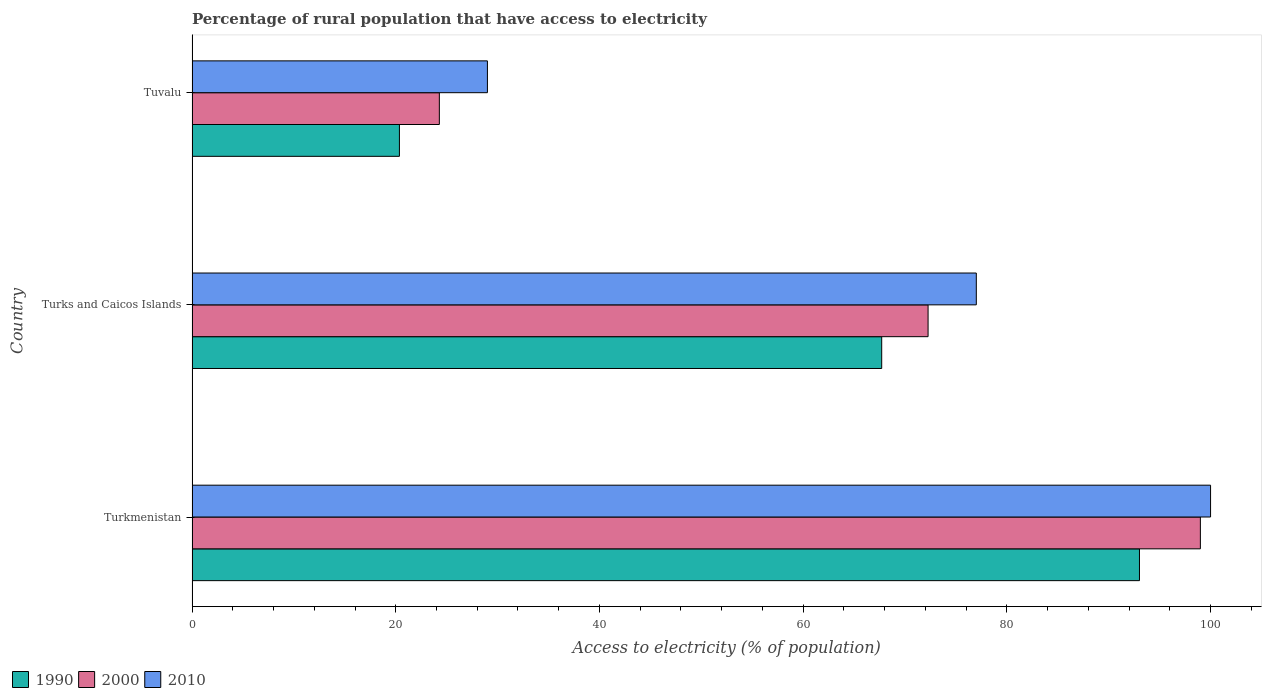How many groups of bars are there?
Your answer should be compact. 3. What is the label of the 3rd group of bars from the top?
Offer a terse response. Turkmenistan. What is the percentage of rural population that have access to electricity in 1990 in Turkmenistan?
Provide a succinct answer. 93.02. In which country was the percentage of rural population that have access to electricity in 2000 maximum?
Give a very brief answer. Turkmenistan. In which country was the percentage of rural population that have access to electricity in 2000 minimum?
Your response must be concise. Tuvalu. What is the total percentage of rural population that have access to electricity in 2010 in the graph?
Offer a very short reply. 206. What is the difference between the percentage of rural population that have access to electricity in 2000 in Tuvalu and the percentage of rural population that have access to electricity in 1990 in Turks and Caicos Islands?
Provide a succinct answer. -43.43. What is the average percentage of rural population that have access to electricity in 2000 per country?
Offer a very short reply. 65.18. What is the difference between the percentage of rural population that have access to electricity in 2000 and percentage of rural population that have access to electricity in 2010 in Turks and Caicos Islands?
Give a very brief answer. -4.73. In how many countries, is the percentage of rural population that have access to electricity in 2000 greater than 52 %?
Your response must be concise. 2. What is the ratio of the percentage of rural population that have access to electricity in 1990 in Turks and Caicos Islands to that in Tuvalu?
Make the answer very short. 3.33. Is the percentage of rural population that have access to electricity in 1990 in Turkmenistan less than that in Turks and Caicos Islands?
Give a very brief answer. No. Is the difference between the percentage of rural population that have access to electricity in 2000 in Turks and Caicos Islands and Tuvalu greater than the difference between the percentage of rural population that have access to electricity in 2010 in Turks and Caicos Islands and Tuvalu?
Provide a short and direct response. No. What is the difference between the highest and the lowest percentage of rural population that have access to electricity in 1990?
Provide a short and direct response. 72.66. Is it the case that in every country, the sum of the percentage of rural population that have access to electricity in 1990 and percentage of rural population that have access to electricity in 2010 is greater than the percentage of rural population that have access to electricity in 2000?
Your response must be concise. Yes. How many bars are there?
Make the answer very short. 9. Are all the bars in the graph horizontal?
Your answer should be compact. Yes. How many countries are there in the graph?
Ensure brevity in your answer.  3. Does the graph contain any zero values?
Provide a succinct answer. No. Where does the legend appear in the graph?
Your response must be concise. Bottom left. How many legend labels are there?
Ensure brevity in your answer.  3. What is the title of the graph?
Ensure brevity in your answer.  Percentage of rural population that have access to electricity. Does "2015" appear as one of the legend labels in the graph?
Your answer should be compact. No. What is the label or title of the X-axis?
Your answer should be very brief. Access to electricity (% of population). What is the Access to electricity (% of population) of 1990 in Turkmenistan?
Your answer should be compact. 93.02. What is the Access to electricity (% of population) in 1990 in Turks and Caicos Islands?
Give a very brief answer. 67.71. What is the Access to electricity (% of population) of 2000 in Turks and Caicos Islands?
Make the answer very short. 72.27. What is the Access to electricity (% of population) of 1990 in Tuvalu?
Offer a very short reply. 20.36. What is the Access to electricity (% of population) in 2000 in Tuvalu?
Provide a succinct answer. 24.28. Across all countries, what is the maximum Access to electricity (% of population) in 1990?
Keep it short and to the point. 93.02. Across all countries, what is the maximum Access to electricity (% of population) of 2000?
Your response must be concise. 99. Across all countries, what is the maximum Access to electricity (% of population) in 2010?
Your answer should be compact. 100. Across all countries, what is the minimum Access to electricity (% of population) in 1990?
Your answer should be very brief. 20.36. Across all countries, what is the minimum Access to electricity (% of population) in 2000?
Offer a terse response. 24.28. Across all countries, what is the minimum Access to electricity (% of population) in 2010?
Make the answer very short. 29. What is the total Access to electricity (% of population) of 1990 in the graph?
Provide a short and direct response. 181.09. What is the total Access to electricity (% of population) of 2000 in the graph?
Give a very brief answer. 195.55. What is the total Access to electricity (% of population) in 2010 in the graph?
Your answer should be very brief. 206. What is the difference between the Access to electricity (% of population) of 1990 in Turkmenistan and that in Turks and Caicos Islands?
Keep it short and to the point. 25.31. What is the difference between the Access to electricity (% of population) of 2000 in Turkmenistan and that in Turks and Caicos Islands?
Provide a succinct answer. 26.73. What is the difference between the Access to electricity (% of population) in 2010 in Turkmenistan and that in Turks and Caicos Islands?
Ensure brevity in your answer.  23. What is the difference between the Access to electricity (% of population) in 1990 in Turkmenistan and that in Tuvalu?
Provide a short and direct response. 72.66. What is the difference between the Access to electricity (% of population) of 2000 in Turkmenistan and that in Tuvalu?
Your answer should be very brief. 74.72. What is the difference between the Access to electricity (% of population) in 1990 in Turks and Caicos Islands and that in Tuvalu?
Your answer should be compact. 47.35. What is the difference between the Access to electricity (% of population) of 2000 in Turks and Caicos Islands and that in Tuvalu?
Offer a terse response. 47.98. What is the difference between the Access to electricity (% of population) of 2010 in Turks and Caicos Islands and that in Tuvalu?
Offer a very short reply. 48. What is the difference between the Access to electricity (% of population) in 1990 in Turkmenistan and the Access to electricity (% of population) in 2000 in Turks and Caicos Islands?
Your answer should be compact. 20.75. What is the difference between the Access to electricity (% of population) of 1990 in Turkmenistan and the Access to electricity (% of population) of 2010 in Turks and Caicos Islands?
Ensure brevity in your answer.  16.02. What is the difference between the Access to electricity (% of population) of 2000 in Turkmenistan and the Access to electricity (% of population) of 2010 in Turks and Caicos Islands?
Keep it short and to the point. 22. What is the difference between the Access to electricity (% of population) of 1990 in Turkmenistan and the Access to electricity (% of population) of 2000 in Tuvalu?
Provide a succinct answer. 68.74. What is the difference between the Access to electricity (% of population) in 1990 in Turkmenistan and the Access to electricity (% of population) in 2010 in Tuvalu?
Your answer should be very brief. 64.02. What is the difference between the Access to electricity (% of population) of 2000 in Turkmenistan and the Access to electricity (% of population) of 2010 in Tuvalu?
Make the answer very short. 70. What is the difference between the Access to electricity (% of population) of 1990 in Turks and Caicos Islands and the Access to electricity (% of population) of 2000 in Tuvalu?
Keep it short and to the point. 43.43. What is the difference between the Access to electricity (% of population) in 1990 in Turks and Caicos Islands and the Access to electricity (% of population) in 2010 in Tuvalu?
Make the answer very short. 38.71. What is the difference between the Access to electricity (% of population) in 2000 in Turks and Caicos Islands and the Access to electricity (% of population) in 2010 in Tuvalu?
Offer a very short reply. 43.27. What is the average Access to electricity (% of population) of 1990 per country?
Your response must be concise. 60.36. What is the average Access to electricity (% of population) in 2000 per country?
Your response must be concise. 65.18. What is the average Access to electricity (% of population) in 2010 per country?
Offer a terse response. 68.67. What is the difference between the Access to electricity (% of population) of 1990 and Access to electricity (% of population) of 2000 in Turkmenistan?
Offer a terse response. -5.98. What is the difference between the Access to electricity (% of population) of 1990 and Access to electricity (% of population) of 2010 in Turkmenistan?
Ensure brevity in your answer.  -6.98. What is the difference between the Access to electricity (% of population) in 2000 and Access to electricity (% of population) in 2010 in Turkmenistan?
Your answer should be compact. -1. What is the difference between the Access to electricity (% of population) of 1990 and Access to electricity (% of population) of 2000 in Turks and Caicos Islands?
Provide a short and direct response. -4.55. What is the difference between the Access to electricity (% of population) of 1990 and Access to electricity (% of population) of 2010 in Turks and Caicos Islands?
Your answer should be compact. -9.29. What is the difference between the Access to electricity (% of population) of 2000 and Access to electricity (% of population) of 2010 in Turks and Caicos Islands?
Give a very brief answer. -4.74. What is the difference between the Access to electricity (% of population) in 1990 and Access to electricity (% of population) in 2000 in Tuvalu?
Offer a terse response. -3.92. What is the difference between the Access to electricity (% of population) in 1990 and Access to electricity (% of population) in 2010 in Tuvalu?
Ensure brevity in your answer.  -8.64. What is the difference between the Access to electricity (% of population) of 2000 and Access to electricity (% of population) of 2010 in Tuvalu?
Give a very brief answer. -4.72. What is the ratio of the Access to electricity (% of population) of 1990 in Turkmenistan to that in Turks and Caicos Islands?
Offer a terse response. 1.37. What is the ratio of the Access to electricity (% of population) in 2000 in Turkmenistan to that in Turks and Caicos Islands?
Provide a short and direct response. 1.37. What is the ratio of the Access to electricity (% of population) in 2010 in Turkmenistan to that in Turks and Caicos Islands?
Ensure brevity in your answer.  1.3. What is the ratio of the Access to electricity (% of population) in 1990 in Turkmenistan to that in Tuvalu?
Offer a very short reply. 4.57. What is the ratio of the Access to electricity (% of population) of 2000 in Turkmenistan to that in Tuvalu?
Offer a very short reply. 4.08. What is the ratio of the Access to electricity (% of population) of 2010 in Turkmenistan to that in Tuvalu?
Your answer should be very brief. 3.45. What is the ratio of the Access to electricity (% of population) in 1990 in Turks and Caicos Islands to that in Tuvalu?
Make the answer very short. 3.33. What is the ratio of the Access to electricity (% of population) of 2000 in Turks and Caicos Islands to that in Tuvalu?
Provide a short and direct response. 2.98. What is the ratio of the Access to electricity (% of population) of 2010 in Turks and Caicos Islands to that in Tuvalu?
Your response must be concise. 2.66. What is the difference between the highest and the second highest Access to electricity (% of population) of 1990?
Make the answer very short. 25.31. What is the difference between the highest and the second highest Access to electricity (% of population) of 2000?
Give a very brief answer. 26.73. What is the difference between the highest and the lowest Access to electricity (% of population) of 1990?
Your answer should be very brief. 72.66. What is the difference between the highest and the lowest Access to electricity (% of population) of 2000?
Give a very brief answer. 74.72. 